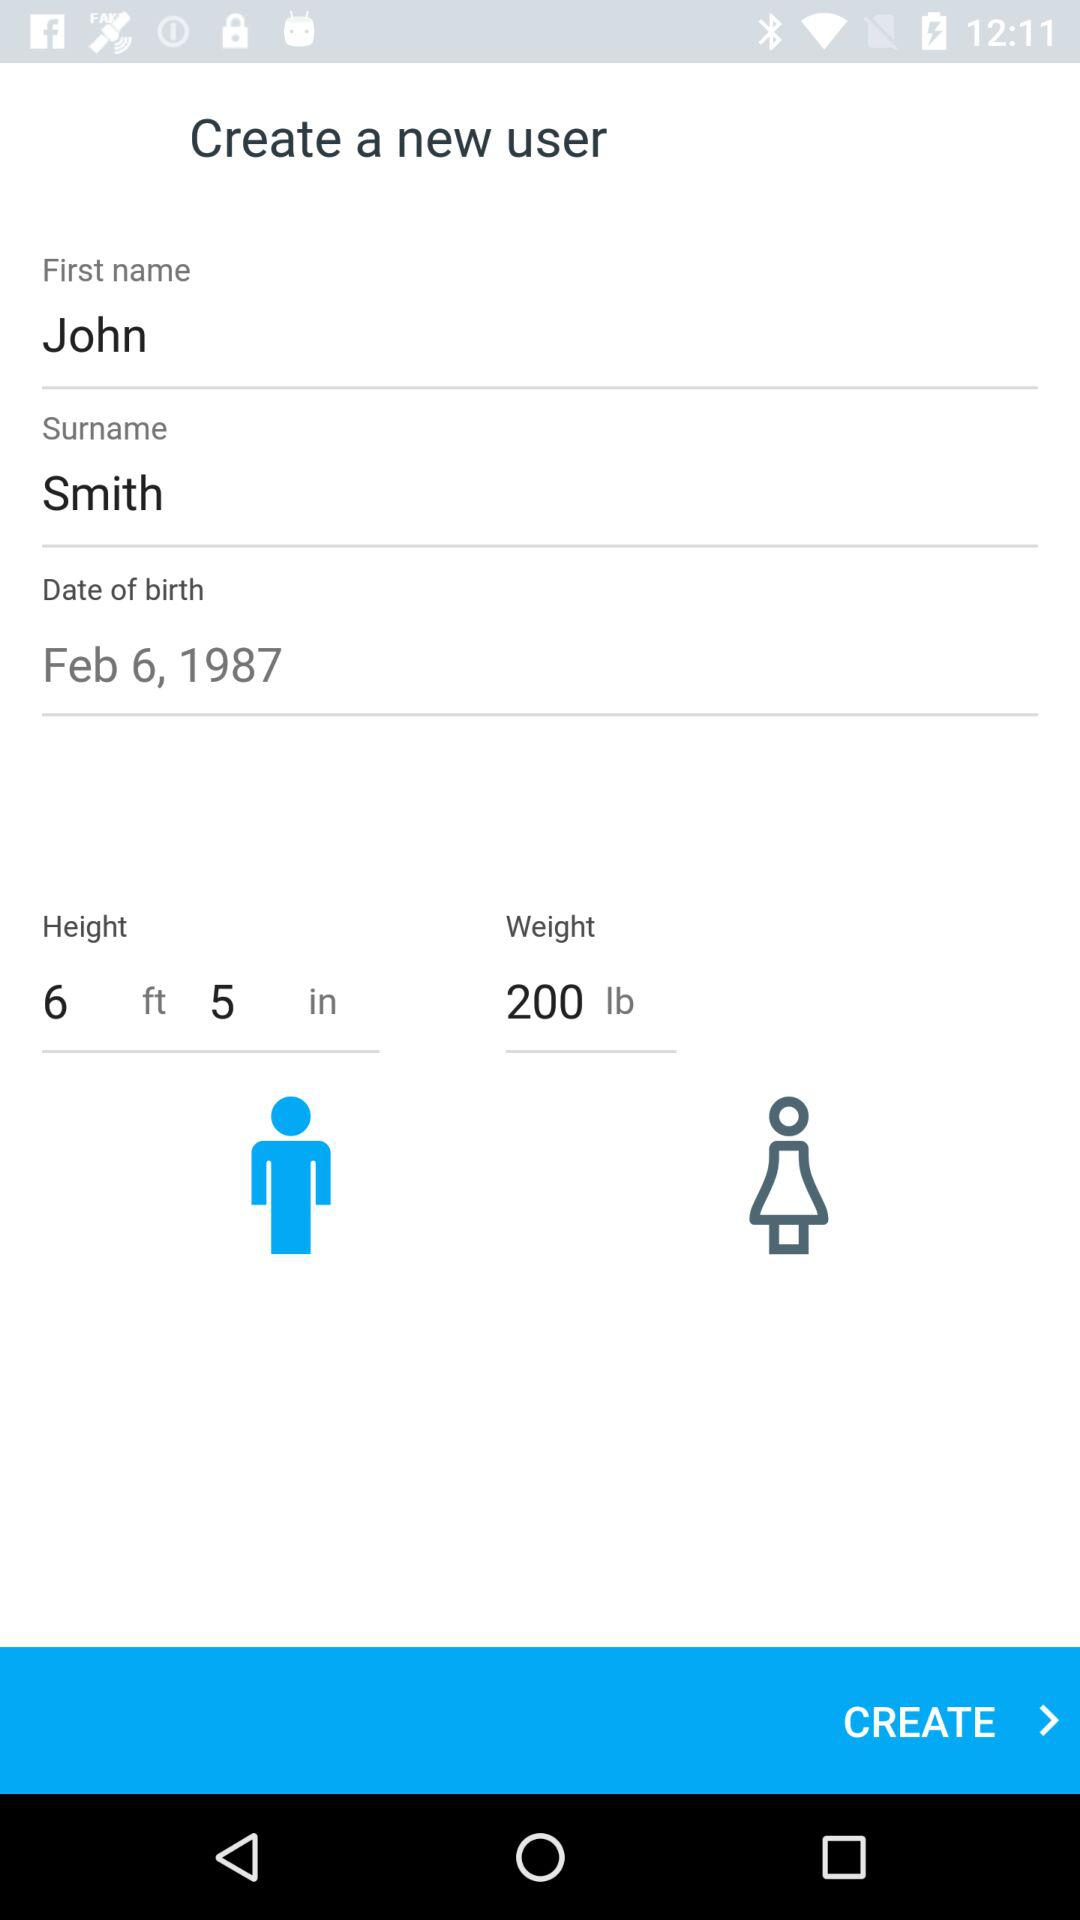What is the date of birth? The date of birth is February 6, 1987. 